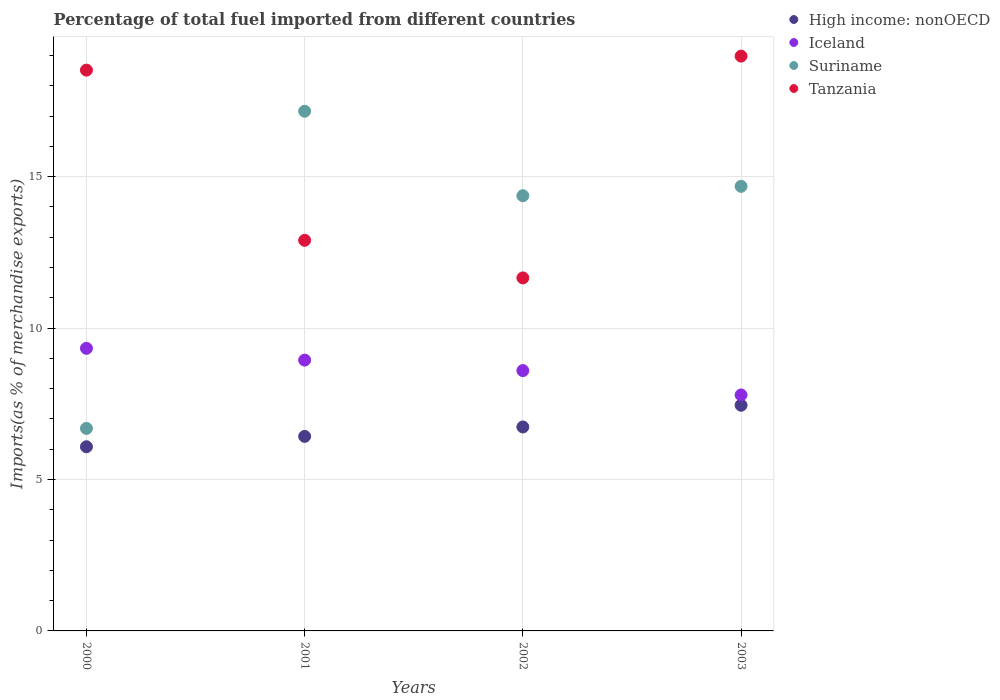How many different coloured dotlines are there?
Your answer should be very brief. 4. What is the percentage of imports to different countries in Tanzania in 2000?
Your answer should be very brief. 18.52. Across all years, what is the maximum percentage of imports to different countries in Tanzania?
Provide a succinct answer. 18.98. Across all years, what is the minimum percentage of imports to different countries in High income: nonOECD?
Provide a succinct answer. 6.08. What is the total percentage of imports to different countries in Tanzania in the graph?
Make the answer very short. 62.05. What is the difference between the percentage of imports to different countries in High income: nonOECD in 2000 and that in 2002?
Give a very brief answer. -0.65. What is the difference between the percentage of imports to different countries in Tanzania in 2002 and the percentage of imports to different countries in Iceland in 2001?
Keep it short and to the point. 2.71. What is the average percentage of imports to different countries in Tanzania per year?
Offer a terse response. 15.51. In the year 2003, what is the difference between the percentage of imports to different countries in Tanzania and percentage of imports to different countries in Suriname?
Give a very brief answer. 4.3. What is the ratio of the percentage of imports to different countries in Tanzania in 2000 to that in 2001?
Your response must be concise. 1.44. Is the difference between the percentage of imports to different countries in Tanzania in 2000 and 2003 greater than the difference between the percentage of imports to different countries in Suriname in 2000 and 2003?
Your response must be concise. Yes. What is the difference between the highest and the second highest percentage of imports to different countries in Iceland?
Provide a short and direct response. 0.39. What is the difference between the highest and the lowest percentage of imports to different countries in Suriname?
Provide a succinct answer. 10.47. In how many years, is the percentage of imports to different countries in Iceland greater than the average percentage of imports to different countries in Iceland taken over all years?
Your answer should be compact. 2. Is it the case that in every year, the sum of the percentage of imports to different countries in Tanzania and percentage of imports to different countries in Suriname  is greater than the sum of percentage of imports to different countries in Iceland and percentage of imports to different countries in High income: nonOECD?
Your response must be concise. Yes. Is it the case that in every year, the sum of the percentage of imports to different countries in Iceland and percentage of imports to different countries in Suriname  is greater than the percentage of imports to different countries in Tanzania?
Your response must be concise. No. Is the percentage of imports to different countries in Tanzania strictly less than the percentage of imports to different countries in Iceland over the years?
Keep it short and to the point. No. What is the difference between two consecutive major ticks on the Y-axis?
Make the answer very short. 5. Does the graph contain any zero values?
Your answer should be compact. No. Does the graph contain grids?
Your answer should be compact. Yes. How many legend labels are there?
Keep it short and to the point. 4. How are the legend labels stacked?
Your answer should be compact. Vertical. What is the title of the graph?
Provide a succinct answer. Percentage of total fuel imported from different countries. Does "Angola" appear as one of the legend labels in the graph?
Offer a very short reply. No. What is the label or title of the X-axis?
Provide a succinct answer. Years. What is the label or title of the Y-axis?
Keep it short and to the point. Imports(as % of merchandise exports). What is the Imports(as % of merchandise exports) in High income: nonOECD in 2000?
Your response must be concise. 6.08. What is the Imports(as % of merchandise exports) of Iceland in 2000?
Your answer should be very brief. 9.33. What is the Imports(as % of merchandise exports) in Suriname in 2000?
Give a very brief answer. 6.69. What is the Imports(as % of merchandise exports) in Tanzania in 2000?
Your answer should be very brief. 18.52. What is the Imports(as % of merchandise exports) of High income: nonOECD in 2001?
Ensure brevity in your answer.  6.42. What is the Imports(as % of merchandise exports) in Iceland in 2001?
Give a very brief answer. 8.94. What is the Imports(as % of merchandise exports) in Suriname in 2001?
Your answer should be very brief. 17.16. What is the Imports(as % of merchandise exports) of Tanzania in 2001?
Give a very brief answer. 12.9. What is the Imports(as % of merchandise exports) in High income: nonOECD in 2002?
Your answer should be very brief. 6.73. What is the Imports(as % of merchandise exports) in Iceland in 2002?
Provide a succinct answer. 8.6. What is the Imports(as % of merchandise exports) of Suriname in 2002?
Offer a terse response. 14.37. What is the Imports(as % of merchandise exports) in Tanzania in 2002?
Keep it short and to the point. 11.66. What is the Imports(as % of merchandise exports) of High income: nonOECD in 2003?
Ensure brevity in your answer.  7.45. What is the Imports(as % of merchandise exports) of Iceland in 2003?
Offer a terse response. 7.79. What is the Imports(as % of merchandise exports) in Suriname in 2003?
Give a very brief answer. 14.68. What is the Imports(as % of merchandise exports) in Tanzania in 2003?
Offer a very short reply. 18.98. Across all years, what is the maximum Imports(as % of merchandise exports) in High income: nonOECD?
Provide a short and direct response. 7.45. Across all years, what is the maximum Imports(as % of merchandise exports) in Iceland?
Keep it short and to the point. 9.33. Across all years, what is the maximum Imports(as % of merchandise exports) in Suriname?
Ensure brevity in your answer.  17.16. Across all years, what is the maximum Imports(as % of merchandise exports) of Tanzania?
Ensure brevity in your answer.  18.98. Across all years, what is the minimum Imports(as % of merchandise exports) of High income: nonOECD?
Offer a terse response. 6.08. Across all years, what is the minimum Imports(as % of merchandise exports) of Iceland?
Provide a succinct answer. 7.79. Across all years, what is the minimum Imports(as % of merchandise exports) in Suriname?
Provide a short and direct response. 6.69. Across all years, what is the minimum Imports(as % of merchandise exports) in Tanzania?
Offer a terse response. 11.66. What is the total Imports(as % of merchandise exports) in High income: nonOECD in the graph?
Your response must be concise. 26.69. What is the total Imports(as % of merchandise exports) of Iceland in the graph?
Your answer should be very brief. 34.66. What is the total Imports(as % of merchandise exports) of Suriname in the graph?
Make the answer very short. 52.9. What is the total Imports(as % of merchandise exports) in Tanzania in the graph?
Ensure brevity in your answer.  62.05. What is the difference between the Imports(as % of merchandise exports) of High income: nonOECD in 2000 and that in 2001?
Your answer should be very brief. -0.34. What is the difference between the Imports(as % of merchandise exports) of Iceland in 2000 and that in 2001?
Provide a short and direct response. 0.39. What is the difference between the Imports(as % of merchandise exports) in Suriname in 2000 and that in 2001?
Your answer should be very brief. -10.47. What is the difference between the Imports(as % of merchandise exports) in Tanzania in 2000 and that in 2001?
Make the answer very short. 5.62. What is the difference between the Imports(as % of merchandise exports) in High income: nonOECD in 2000 and that in 2002?
Your response must be concise. -0.65. What is the difference between the Imports(as % of merchandise exports) of Iceland in 2000 and that in 2002?
Provide a short and direct response. 0.73. What is the difference between the Imports(as % of merchandise exports) of Suriname in 2000 and that in 2002?
Offer a very short reply. -7.68. What is the difference between the Imports(as % of merchandise exports) in Tanzania in 2000 and that in 2002?
Ensure brevity in your answer.  6.86. What is the difference between the Imports(as % of merchandise exports) in High income: nonOECD in 2000 and that in 2003?
Your answer should be very brief. -1.37. What is the difference between the Imports(as % of merchandise exports) of Iceland in 2000 and that in 2003?
Your answer should be compact. 1.54. What is the difference between the Imports(as % of merchandise exports) of Suriname in 2000 and that in 2003?
Your answer should be very brief. -7.99. What is the difference between the Imports(as % of merchandise exports) in Tanzania in 2000 and that in 2003?
Offer a very short reply. -0.46. What is the difference between the Imports(as % of merchandise exports) of High income: nonOECD in 2001 and that in 2002?
Provide a short and direct response. -0.31. What is the difference between the Imports(as % of merchandise exports) in Iceland in 2001 and that in 2002?
Ensure brevity in your answer.  0.35. What is the difference between the Imports(as % of merchandise exports) of Suriname in 2001 and that in 2002?
Keep it short and to the point. 2.79. What is the difference between the Imports(as % of merchandise exports) of Tanzania in 2001 and that in 2002?
Ensure brevity in your answer.  1.24. What is the difference between the Imports(as % of merchandise exports) of High income: nonOECD in 2001 and that in 2003?
Your answer should be compact. -1.03. What is the difference between the Imports(as % of merchandise exports) in Iceland in 2001 and that in 2003?
Offer a very short reply. 1.15. What is the difference between the Imports(as % of merchandise exports) of Suriname in 2001 and that in 2003?
Offer a very short reply. 2.48. What is the difference between the Imports(as % of merchandise exports) in Tanzania in 2001 and that in 2003?
Offer a very short reply. -6.08. What is the difference between the Imports(as % of merchandise exports) in High income: nonOECD in 2002 and that in 2003?
Offer a terse response. -0.72. What is the difference between the Imports(as % of merchandise exports) of Iceland in 2002 and that in 2003?
Give a very brief answer. 0.8. What is the difference between the Imports(as % of merchandise exports) of Suriname in 2002 and that in 2003?
Keep it short and to the point. -0.31. What is the difference between the Imports(as % of merchandise exports) in Tanzania in 2002 and that in 2003?
Your response must be concise. -7.32. What is the difference between the Imports(as % of merchandise exports) in High income: nonOECD in 2000 and the Imports(as % of merchandise exports) in Iceland in 2001?
Give a very brief answer. -2.86. What is the difference between the Imports(as % of merchandise exports) in High income: nonOECD in 2000 and the Imports(as % of merchandise exports) in Suriname in 2001?
Your response must be concise. -11.08. What is the difference between the Imports(as % of merchandise exports) of High income: nonOECD in 2000 and the Imports(as % of merchandise exports) of Tanzania in 2001?
Provide a short and direct response. -6.82. What is the difference between the Imports(as % of merchandise exports) in Iceland in 2000 and the Imports(as % of merchandise exports) in Suriname in 2001?
Make the answer very short. -7.83. What is the difference between the Imports(as % of merchandise exports) in Iceland in 2000 and the Imports(as % of merchandise exports) in Tanzania in 2001?
Make the answer very short. -3.57. What is the difference between the Imports(as % of merchandise exports) in Suriname in 2000 and the Imports(as % of merchandise exports) in Tanzania in 2001?
Provide a short and direct response. -6.21. What is the difference between the Imports(as % of merchandise exports) in High income: nonOECD in 2000 and the Imports(as % of merchandise exports) in Iceland in 2002?
Keep it short and to the point. -2.52. What is the difference between the Imports(as % of merchandise exports) of High income: nonOECD in 2000 and the Imports(as % of merchandise exports) of Suriname in 2002?
Provide a short and direct response. -8.29. What is the difference between the Imports(as % of merchandise exports) in High income: nonOECD in 2000 and the Imports(as % of merchandise exports) in Tanzania in 2002?
Ensure brevity in your answer.  -5.58. What is the difference between the Imports(as % of merchandise exports) in Iceland in 2000 and the Imports(as % of merchandise exports) in Suriname in 2002?
Offer a terse response. -5.04. What is the difference between the Imports(as % of merchandise exports) in Iceland in 2000 and the Imports(as % of merchandise exports) in Tanzania in 2002?
Provide a succinct answer. -2.33. What is the difference between the Imports(as % of merchandise exports) in Suriname in 2000 and the Imports(as % of merchandise exports) in Tanzania in 2002?
Make the answer very short. -4.97. What is the difference between the Imports(as % of merchandise exports) of High income: nonOECD in 2000 and the Imports(as % of merchandise exports) of Iceland in 2003?
Your response must be concise. -1.71. What is the difference between the Imports(as % of merchandise exports) of High income: nonOECD in 2000 and the Imports(as % of merchandise exports) of Suriname in 2003?
Provide a succinct answer. -8.6. What is the difference between the Imports(as % of merchandise exports) in High income: nonOECD in 2000 and the Imports(as % of merchandise exports) in Tanzania in 2003?
Give a very brief answer. -12.9. What is the difference between the Imports(as % of merchandise exports) in Iceland in 2000 and the Imports(as % of merchandise exports) in Suriname in 2003?
Ensure brevity in your answer.  -5.35. What is the difference between the Imports(as % of merchandise exports) of Iceland in 2000 and the Imports(as % of merchandise exports) of Tanzania in 2003?
Your response must be concise. -9.65. What is the difference between the Imports(as % of merchandise exports) of Suriname in 2000 and the Imports(as % of merchandise exports) of Tanzania in 2003?
Provide a succinct answer. -12.29. What is the difference between the Imports(as % of merchandise exports) of High income: nonOECD in 2001 and the Imports(as % of merchandise exports) of Iceland in 2002?
Your response must be concise. -2.17. What is the difference between the Imports(as % of merchandise exports) of High income: nonOECD in 2001 and the Imports(as % of merchandise exports) of Suriname in 2002?
Offer a terse response. -7.95. What is the difference between the Imports(as % of merchandise exports) of High income: nonOECD in 2001 and the Imports(as % of merchandise exports) of Tanzania in 2002?
Your answer should be compact. -5.23. What is the difference between the Imports(as % of merchandise exports) in Iceland in 2001 and the Imports(as % of merchandise exports) in Suriname in 2002?
Offer a very short reply. -5.43. What is the difference between the Imports(as % of merchandise exports) of Iceland in 2001 and the Imports(as % of merchandise exports) of Tanzania in 2002?
Give a very brief answer. -2.71. What is the difference between the Imports(as % of merchandise exports) of Suriname in 2001 and the Imports(as % of merchandise exports) of Tanzania in 2002?
Ensure brevity in your answer.  5.5. What is the difference between the Imports(as % of merchandise exports) of High income: nonOECD in 2001 and the Imports(as % of merchandise exports) of Iceland in 2003?
Give a very brief answer. -1.37. What is the difference between the Imports(as % of merchandise exports) of High income: nonOECD in 2001 and the Imports(as % of merchandise exports) of Suriname in 2003?
Provide a succinct answer. -8.26. What is the difference between the Imports(as % of merchandise exports) of High income: nonOECD in 2001 and the Imports(as % of merchandise exports) of Tanzania in 2003?
Offer a terse response. -12.56. What is the difference between the Imports(as % of merchandise exports) of Iceland in 2001 and the Imports(as % of merchandise exports) of Suriname in 2003?
Your response must be concise. -5.74. What is the difference between the Imports(as % of merchandise exports) in Iceland in 2001 and the Imports(as % of merchandise exports) in Tanzania in 2003?
Make the answer very short. -10.04. What is the difference between the Imports(as % of merchandise exports) of Suriname in 2001 and the Imports(as % of merchandise exports) of Tanzania in 2003?
Your answer should be very brief. -1.82. What is the difference between the Imports(as % of merchandise exports) in High income: nonOECD in 2002 and the Imports(as % of merchandise exports) in Iceland in 2003?
Your answer should be compact. -1.06. What is the difference between the Imports(as % of merchandise exports) of High income: nonOECD in 2002 and the Imports(as % of merchandise exports) of Suriname in 2003?
Provide a succinct answer. -7.94. What is the difference between the Imports(as % of merchandise exports) of High income: nonOECD in 2002 and the Imports(as % of merchandise exports) of Tanzania in 2003?
Ensure brevity in your answer.  -12.25. What is the difference between the Imports(as % of merchandise exports) of Iceland in 2002 and the Imports(as % of merchandise exports) of Suriname in 2003?
Provide a short and direct response. -6.08. What is the difference between the Imports(as % of merchandise exports) in Iceland in 2002 and the Imports(as % of merchandise exports) in Tanzania in 2003?
Your response must be concise. -10.38. What is the difference between the Imports(as % of merchandise exports) in Suriname in 2002 and the Imports(as % of merchandise exports) in Tanzania in 2003?
Offer a very short reply. -4.61. What is the average Imports(as % of merchandise exports) in High income: nonOECD per year?
Your response must be concise. 6.67. What is the average Imports(as % of merchandise exports) in Iceland per year?
Keep it short and to the point. 8.67. What is the average Imports(as % of merchandise exports) in Suriname per year?
Your answer should be compact. 13.22. What is the average Imports(as % of merchandise exports) in Tanzania per year?
Keep it short and to the point. 15.51. In the year 2000, what is the difference between the Imports(as % of merchandise exports) of High income: nonOECD and Imports(as % of merchandise exports) of Iceland?
Your answer should be compact. -3.25. In the year 2000, what is the difference between the Imports(as % of merchandise exports) of High income: nonOECD and Imports(as % of merchandise exports) of Suriname?
Offer a terse response. -0.61. In the year 2000, what is the difference between the Imports(as % of merchandise exports) in High income: nonOECD and Imports(as % of merchandise exports) in Tanzania?
Offer a very short reply. -12.44. In the year 2000, what is the difference between the Imports(as % of merchandise exports) in Iceland and Imports(as % of merchandise exports) in Suriname?
Your response must be concise. 2.64. In the year 2000, what is the difference between the Imports(as % of merchandise exports) in Iceland and Imports(as % of merchandise exports) in Tanzania?
Ensure brevity in your answer.  -9.19. In the year 2000, what is the difference between the Imports(as % of merchandise exports) of Suriname and Imports(as % of merchandise exports) of Tanzania?
Ensure brevity in your answer.  -11.83. In the year 2001, what is the difference between the Imports(as % of merchandise exports) of High income: nonOECD and Imports(as % of merchandise exports) of Iceland?
Keep it short and to the point. -2.52. In the year 2001, what is the difference between the Imports(as % of merchandise exports) in High income: nonOECD and Imports(as % of merchandise exports) in Suriname?
Provide a succinct answer. -10.74. In the year 2001, what is the difference between the Imports(as % of merchandise exports) of High income: nonOECD and Imports(as % of merchandise exports) of Tanzania?
Offer a terse response. -6.47. In the year 2001, what is the difference between the Imports(as % of merchandise exports) of Iceland and Imports(as % of merchandise exports) of Suriname?
Your response must be concise. -8.22. In the year 2001, what is the difference between the Imports(as % of merchandise exports) of Iceland and Imports(as % of merchandise exports) of Tanzania?
Ensure brevity in your answer.  -3.95. In the year 2001, what is the difference between the Imports(as % of merchandise exports) in Suriname and Imports(as % of merchandise exports) in Tanzania?
Provide a succinct answer. 4.26. In the year 2002, what is the difference between the Imports(as % of merchandise exports) in High income: nonOECD and Imports(as % of merchandise exports) in Iceland?
Offer a terse response. -1.86. In the year 2002, what is the difference between the Imports(as % of merchandise exports) of High income: nonOECD and Imports(as % of merchandise exports) of Suriname?
Offer a very short reply. -7.64. In the year 2002, what is the difference between the Imports(as % of merchandise exports) of High income: nonOECD and Imports(as % of merchandise exports) of Tanzania?
Your answer should be compact. -4.92. In the year 2002, what is the difference between the Imports(as % of merchandise exports) in Iceland and Imports(as % of merchandise exports) in Suriname?
Your response must be concise. -5.77. In the year 2002, what is the difference between the Imports(as % of merchandise exports) of Iceland and Imports(as % of merchandise exports) of Tanzania?
Your response must be concise. -3.06. In the year 2002, what is the difference between the Imports(as % of merchandise exports) in Suriname and Imports(as % of merchandise exports) in Tanzania?
Provide a succinct answer. 2.71. In the year 2003, what is the difference between the Imports(as % of merchandise exports) of High income: nonOECD and Imports(as % of merchandise exports) of Iceland?
Ensure brevity in your answer.  -0.34. In the year 2003, what is the difference between the Imports(as % of merchandise exports) in High income: nonOECD and Imports(as % of merchandise exports) in Suriname?
Offer a very short reply. -7.23. In the year 2003, what is the difference between the Imports(as % of merchandise exports) of High income: nonOECD and Imports(as % of merchandise exports) of Tanzania?
Offer a terse response. -11.53. In the year 2003, what is the difference between the Imports(as % of merchandise exports) in Iceland and Imports(as % of merchandise exports) in Suriname?
Provide a short and direct response. -6.89. In the year 2003, what is the difference between the Imports(as % of merchandise exports) of Iceland and Imports(as % of merchandise exports) of Tanzania?
Ensure brevity in your answer.  -11.19. In the year 2003, what is the difference between the Imports(as % of merchandise exports) in Suriname and Imports(as % of merchandise exports) in Tanzania?
Provide a succinct answer. -4.3. What is the ratio of the Imports(as % of merchandise exports) in High income: nonOECD in 2000 to that in 2001?
Give a very brief answer. 0.95. What is the ratio of the Imports(as % of merchandise exports) of Iceland in 2000 to that in 2001?
Give a very brief answer. 1.04. What is the ratio of the Imports(as % of merchandise exports) of Suriname in 2000 to that in 2001?
Offer a very short reply. 0.39. What is the ratio of the Imports(as % of merchandise exports) of Tanzania in 2000 to that in 2001?
Keep it short and to the point. 1.44. What is the ratio of the Imports(as % of merchandise exports) of High income: nonOECD in 2000 to that in 2002?
Keep it short and to the point. 0.9. What is the ratio of the Imports(as % of merchandise exports) in Iceland in 2000 to that in 2002?
Offer a very short reply. 1.09. What is the ratio of the Imports(as % of merchandise exports) in Suriname in 2000 to that in 2002?
Offer a terse response. 0.47. What is the ratio of the Imports(as % of merchandise exports) of Tanzania in 2000 to that in 2002?
Your answer should be very brief. 1.59. What is the ratio of the Imports(as % of merchandise exports) in High income: nonOECD in 2000 to that in 2003?
Keep it short and to the point. 0.82. What is the ratio of the Imports(as % of merchandise exports) in Iceland in 2000 to that in 2003?
Give a very brief answer. 1.2. What is the ratio of the Imports(as % of merchandise exports) of Suriname in 2000 to that in 2003?
Give a very brief answer. 0.46. What is the ratio of the Imports(as % of merchandise exports) of Tanzania in 2000 to that in 2003?
Make the answer very short. 0.98. What is the ratio of the Imports(as % of merchandise exports) of High income: nonOECD in 2001 to that in 2002?
Make the answer very short. 0.95. What is the ratio of the Imports(as % of merchandise exports) of Iceland in 2001 to that in 2002?
Make the answer very short. 1.04. What is the ratio of the Imports(as % of merchandise exports) in Suriname in 2001 to that in 2002?
Provide a succinct answer. 1.19. What is the ratio of the Imports(as % of merchandise exports) in Tanzania in 2001 to that in 2002?
Give a very brief answer. 1.11. What is the ratio of the Imports(as % of merchandise exports) in High income: nonOECD in 2001 to that in 2003?
Offer a terse response. 0.86. What is the ratio of the Imports(as % of merchandise exports) of Iceland in 2001 to that in 2003?
Make the answer very short. 1.15. What is the ratio of the Imports(as % of merchandise exports) in Suriname in 2001 to that in 2003?
Keep it short and to the point. 1.17. What is the ratio of the Imports(as % of merchandise exports) in Tanzania in 2001 to that in 2003?
Ensure brevity in your answer.  0.68. What is the ratio of the Imports(as % of merchandise exports) of High income: nonOECD in 2002 to that in 2003?
Give a very brief answer. 0.9. What is the ratio of the Imports(as % of merchandise exports) in Iceland in 2002 to that in 2003?
Give a very brief answer. 1.1. What is the ratio of the Imports(as % of merchandise exports) of Suriname in 2002 to that in 2003?
Keep it short and to the point. 0.98. What is the ratio of the Imports(as % of merchandise exports) of Tanzania in 2002 to that in 2003?
Make the answer very short. 0.61. What is the difference between the highest and the second highest Imports(as % of merchandise exports) in High income: nonOECD?
Give a very brief answer. 0.72. What is the difference between the highest and the second highest Imports(as % of merchandise exports) of Iceland?
Offer a very short reply. 0.39. What is the difference between the highest and the second highest Imports(as % of merchandise exports) of Suriname?
Your response must be concise. 2.48. What is the difference between the highest and the second highest Imports(as % of merchandise exports) of Tanzania?
Ensure brevity in your answer.  0.46. What is the difference between the highest and the lowest Imports(as % of merchandise exports) in High income: nonOECD?
Provide a short and direct response. 1.37. What is the difference between the highest and the lowest Imports(as % of merchandise exports) in Iceland?
Give a very brief answer. 1.54. What is the difference between the highest and the lowest Imports(as % of merchandise exports) in Suriname?
Make the answer very short. 10.47. What is the difference between the highest and the lowest Imports(as % of merchandise exports) in Tanzania?
Offer a terse response. 7.32. 